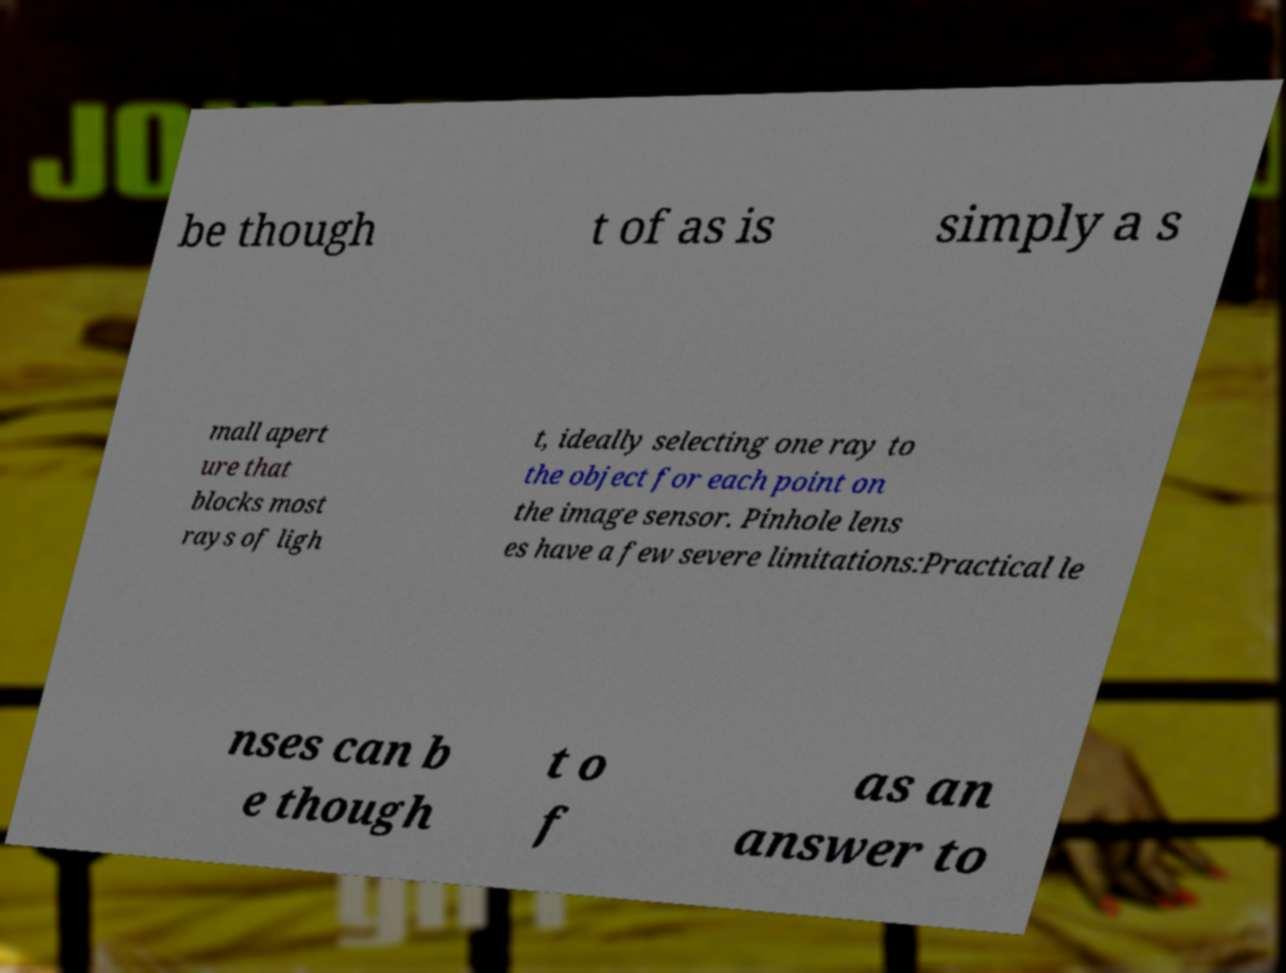Please read and relay the text visible in this image. What does it say? be though t of as is simply a s mall apert ure that blocks most rays of ligh t, ideally selecting one ray to the object for each point on the image sensor. Pinhole lens es have a few severe limitations:Practical le nses can b e though t o f as an answer to 